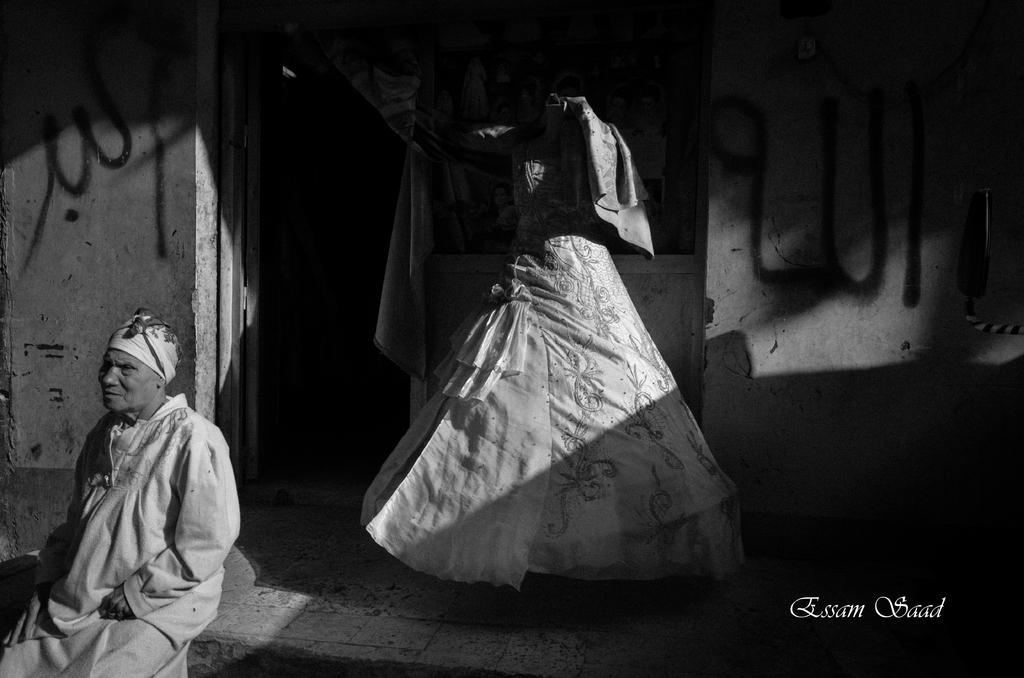What is the main subject in the image? There is a mannequin in the image. Where is the mannequin located? The mannequin is in front of a room. Is there anyone else in the image besides the mannequin? Yes, there is a person sitting on the floor beside the mannequin. How is the image presented? The image is black and white. What historical event is being depicted in the image? There is no historical event depicted in the image; it features a mannequin in front of a room with a person sitting beside it. What type of station is shown in the image? There is no station present in the image; it is a black and white photograph of a mannequin and a person sitting beside it. 